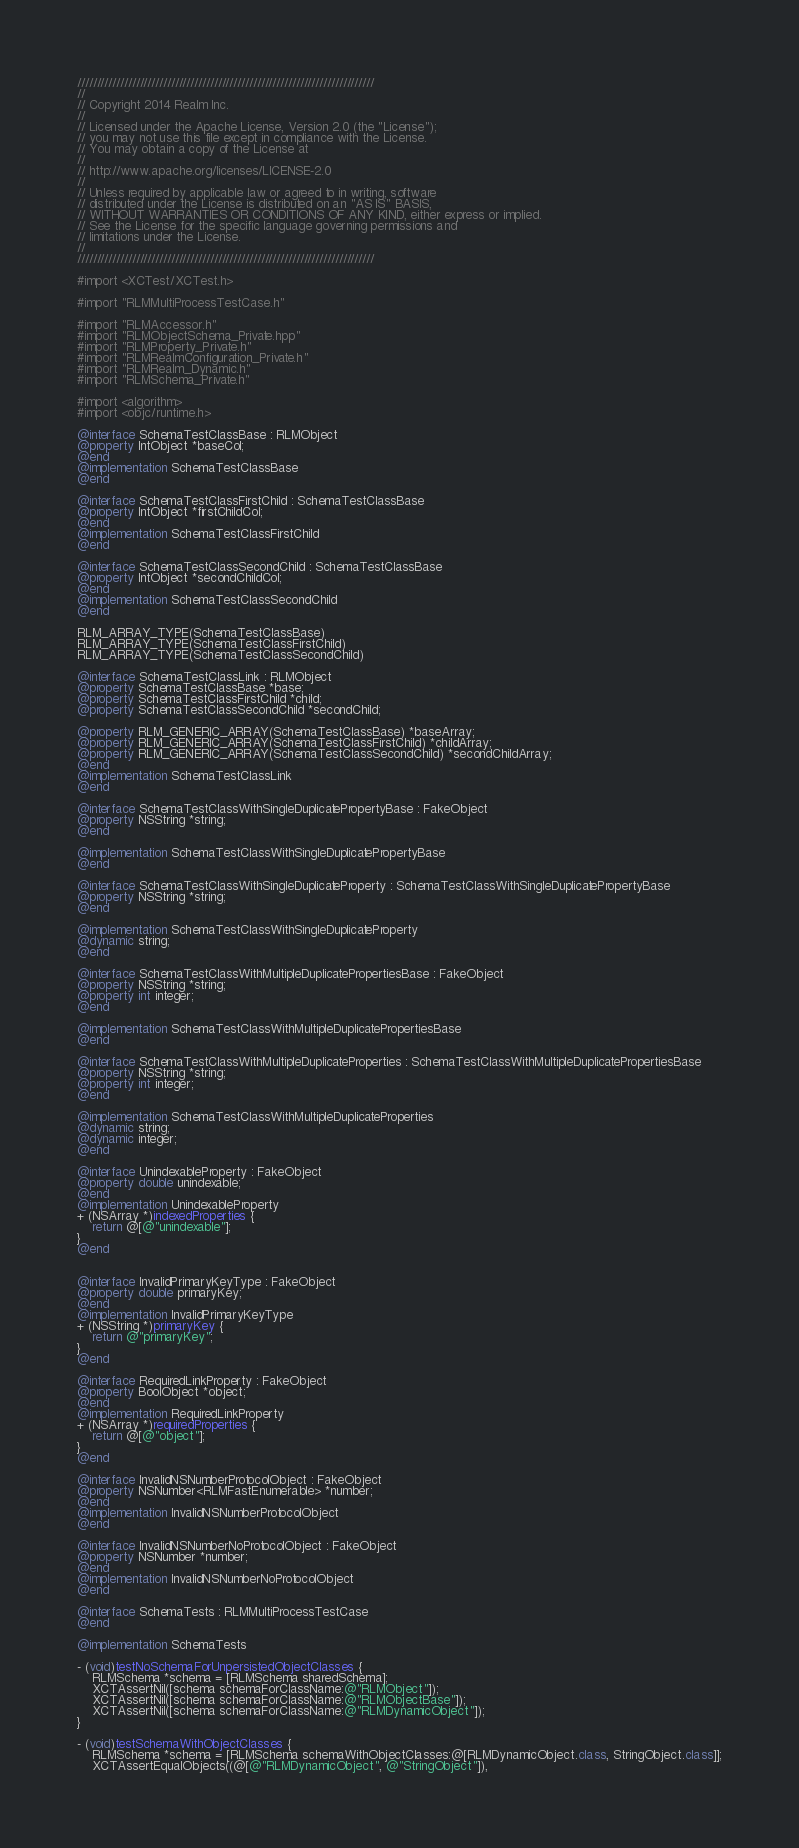<code> <loc_0><loc_0><loc_500><loc_500><_ObjectiveC_>////////////////////////////////////////////////////////////////////////////
//
// Copyright 2014 Realm Inc.
//
// Licensed under the Apache License, Version 2.0 (the "License");
// you may not use this file except in compliance with the License.
// You may obtain a copy of the License at
//
// http://www.apache.org/licenses/LICENSE-2.0
//
// Unless required by applicable law or agreed to in writing, software
// distributed under the License is distributed on an "AS IS" BASIS,
// WITHOUT WARRANTIES OR CONDITIONS OF ANY KIND, either express or implied.
// See the License for the specific language governing permissions and
// limitations under the License.
//
////////////////////////////////////////////////////////////////////////////

#import <XCTest/XCTest.h>

#import "RLMMultiProcessTestCase.h"

#import "RLMAccessor.h"
#import "RLMObjectSchema_Private.hpp"
#import "RLMProperty_Private.h"
#import "RLMRealmConfiguration_Private.h"
#import "RLMRealm_Dynamic.h"
#import "RLMSchema_Private.h"

#import <algorithm>
#import <objc/runtime.h>

@interface SchemaTestClassBase : RLMObject
@property IntObject *baseCol;
@end
@implementation SchemaTestClassBase
@end

@interface SchemaTestClassFirstChild : SchemaTestClassBase
@property IntObject *firstChildCol;
@end
@implementation SchemaTestClassFirstChild
@end

@interface SchemaTestClassSecondChild : SchemaTestClassBase
@property IntObject *secondChildCol;
@end
@implementation SchemaTestClassSecondChild
@end

RLM_ARRAY_TYPE(SchemaTestClassBase)
RLM_ARRAY_TYPE(SchemaTestClassFirstChild)
RLM_ARRAY_TYPE(SchemaTestClassSecondChild)

@interface SchemaTestClassLink : RLMObject
@property SchemaTestClassBase *base;
@property SchemaTestClassFirstChild *child;
@property SchemaTestClassSecondChild *secondChild;

@property RLM_GENERIC_ARRAY(SchemaTestClassBase) *baseArray;
@property RLM_GENERIC_ARRAY(SchemaTestClassFirstChild) *childArray;
@property RLM_GENERIC_ARRAY(SchemaTestClassSecondChild) *secondChildArray;
@end
@implementation SchemaTestClassLink
@end

@interface SchemaTestClassWithSingleDuplicatePropertyBase : FakeObject
@property NSString *string;
@end

@implementation SchemaTestClassWithSingleDuplicatePropertyBase
@end

@interface SchemaTestClassWithSingleDuplicateProperty : SchemaTestClassWithSingleDuplicatePropertyBase
@property NSString *string;
@end

@implementation SchemaTestClassWithSingleDuplicateProperty
@dynamic string;
@end

@interface SchemaTestClassWithMultipleDuplicatePropertiesBase : FakeObject
@property NSString *string;
@property int integer;
@end

@implementation SchemaTestClassWithMultipleDuplicatePropertiesBase
@end

@interface SchemaTestClassWithMultipleDuplicateProperties : SchemaTestClassWithMultipleDuplicatePropertiesBase
@property NSString *string;
@property int integer;
@end

@implementation SchemaTestClassWithMultipleDuplicateProperties
@dynamic string;
@dynamic integer;
@end

@interface UnindexableProperty : FakeObject
@property double unindexable;
@end
@implementation UnindexableProperty
+ (NSArray *)indexedProperties {
    return @[@"unindexable"];
}
@end


@interface InvalidPrimaryKeyType : FakeObject
@property double primaryKey;
@end
@implementation InvalidPrimaryKeyType
+ (NSString *)primaryKey {
    return @"primaryKey";
}
@end

@interface RequiredLinkProperty : FakeObject
@property BoolObject *object;
@end
@implementation RequiredLinkProperty
+ (NSArray *)requiredProperties {
    return @[@"object"];
}
@end

@interface InvalidNSNumberProtocolObject : FakeObject
@property NSNumber<RLMFastEnumerable> *number;
@end
@implementation InvalidNSNumberProtocolObject
@end

@interface InvalidNSNumberNoProtocolObject : FakeObject
@property NSNumber *number;
@end
@implementation InvalidNSNumberNoProtocolObject
@end

@interface SchemaTests : RLMMultiProcessTestCase
@end

@implementation SchemaTests

- (void)testNoSchemaForUnpersistedObjectClasses {
    RLMSchema *schema = [RLMSchema sharedSchema];
    XCTAssertNil([schema schemaForClassName:@"RLMObject"]);
    XCTAssertNil([schema schemaForClassName:@"RLMObjectBase"]);
    XCTAssertNil([schema schemaForClassName:@"RLMDynamicObject"]);
}

- (void)testSchemaWithObjectClasses {
    RLMSchema *schema = [RLMSchema schemaWithObjectClasses:@[RLMDynamicObject.class, StringObject.class]];
    XCTAssertEqualObjects((@[@"RLMDynamicObject", @"StringObject"]),</code> 